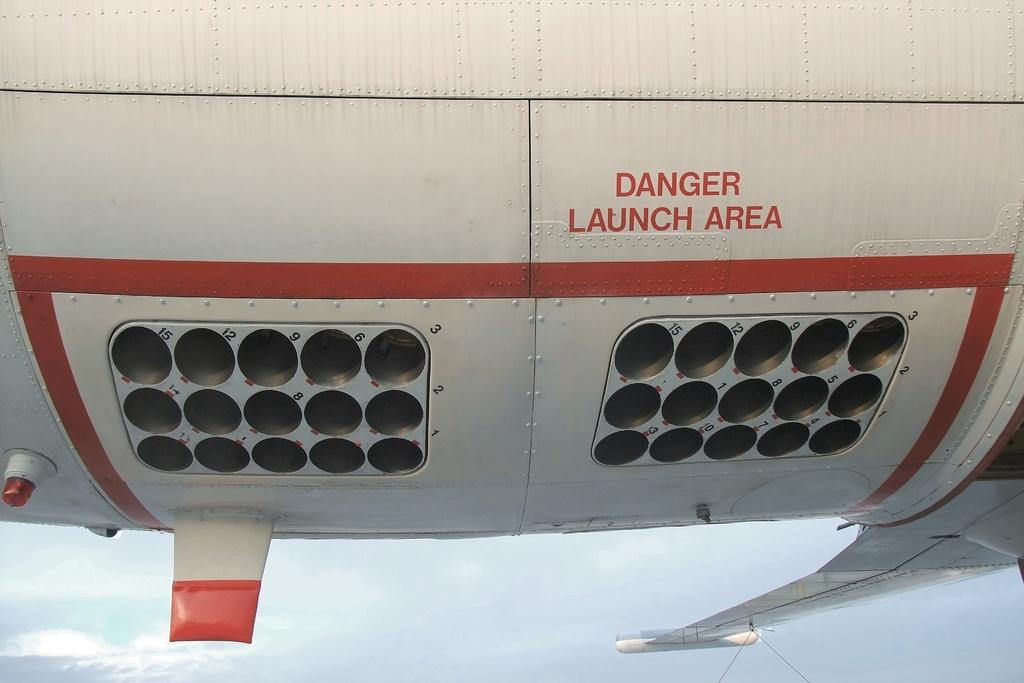What is the main subject of the image? The main subject of the image is an aircraft. How is the aircraft depicted in the image? The aircraft appears to be truncated in the image. What can be seen in the background of the image? The sky is visible in the image. What is written or displayed on the aircraft? There is text on the aircraft. Are there any numbers visible on the aircraft? Yes, there are numbers on the aircraft. Is there any lighting feature on the aircraft? Yes, there is a light on the aircraft. What type of chain can be seen hanging from the roof of the aircraft in the image? There is no chain or roof present in the image; it features an aircraft with text, numbers, and a light. 